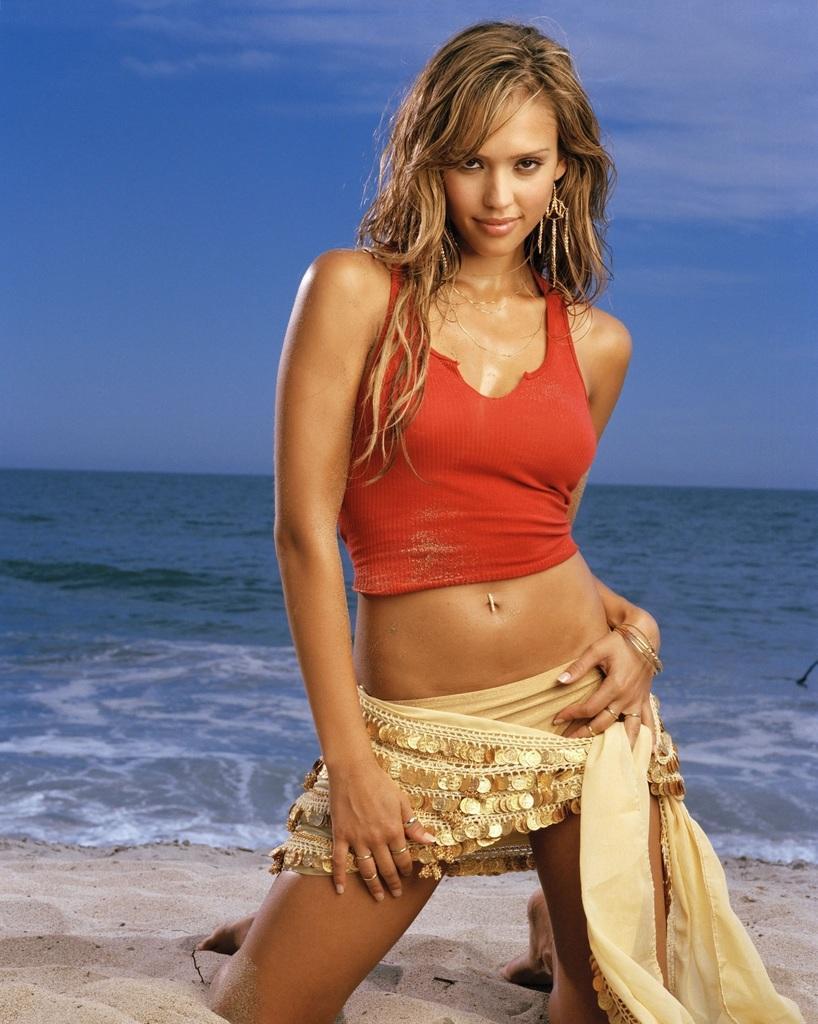Can you describe this image briefly? In the center of the image we can see a lady. At the bottom there is sand. In the background there is a sea. At the top we can see sky. 